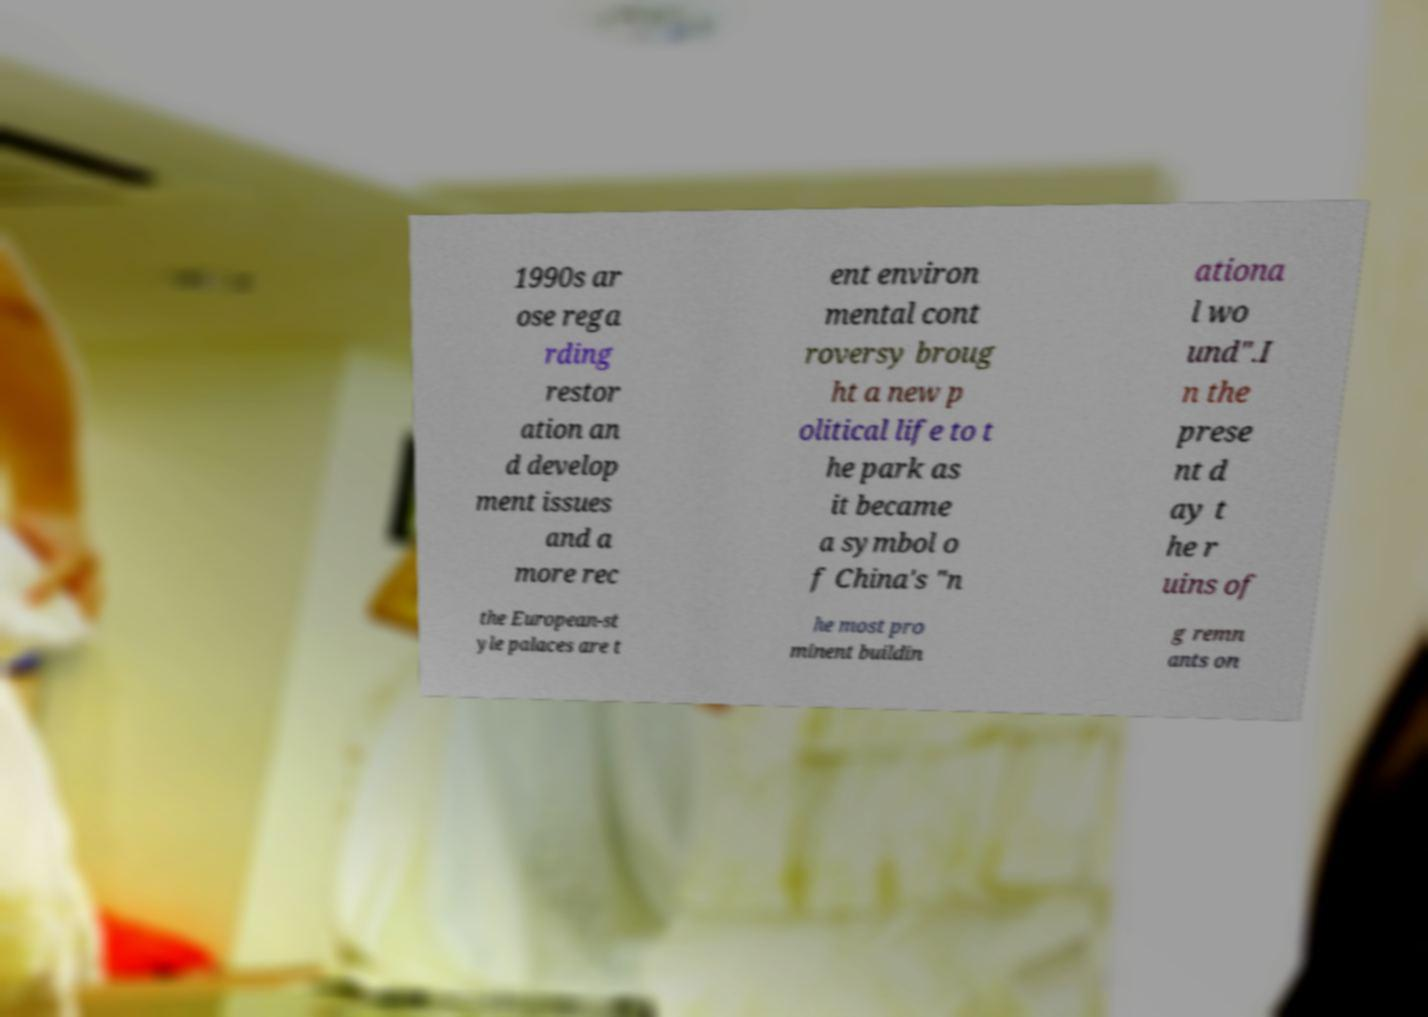There's text embedded in this image that I need extracted. Can you transcribe it verbatim? 1990s ar ose rega rding restor ation an d develop ment issues and a more rec ent environ mental cont roversy broug ht a new p olitical life to t he park as it became a symbol o f China's "n ationa l wo und".I n the prese nt d ay t he r uins of the European-st yle palaces are t he most pro minent buildin g remn ants on 